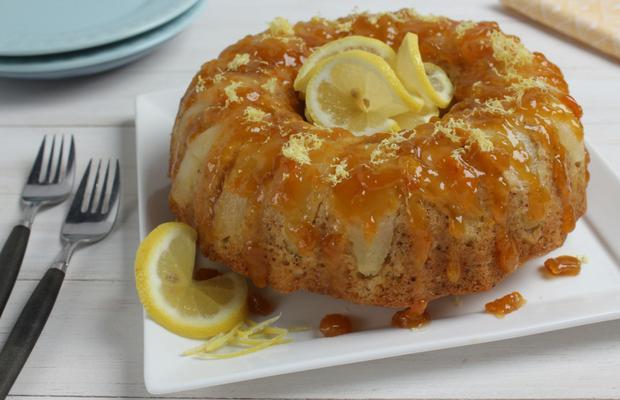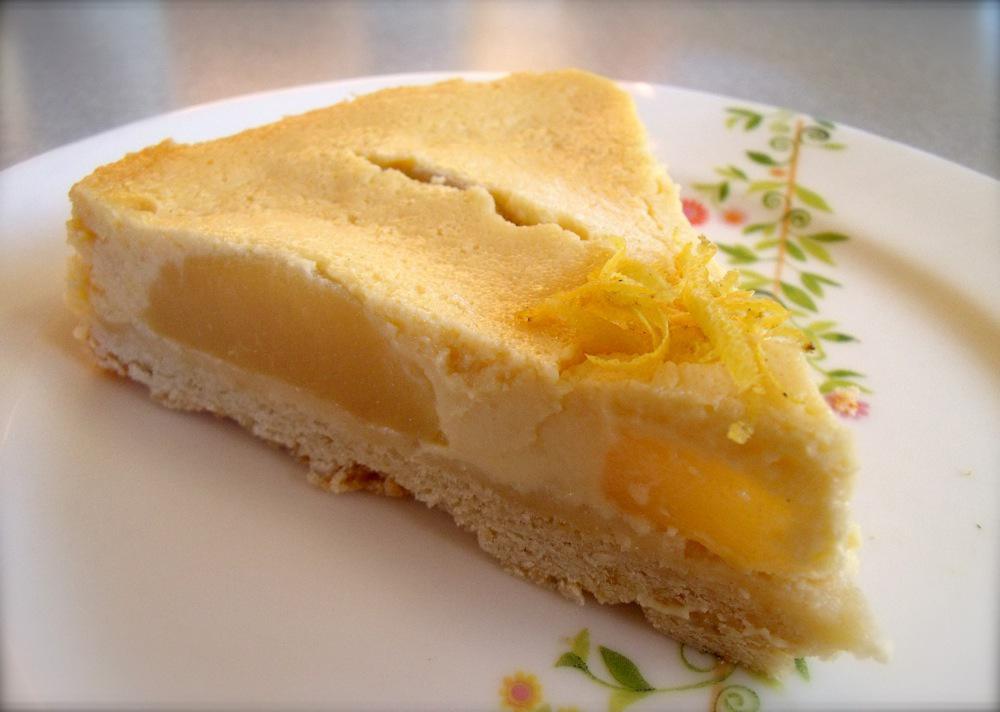The first image is the image on the left, the second image is the image on the right. Analyze the images presented: Is the assertion "there is cake with lemons being used as decorations and a metal utencil is near the cake" valid? Answer yes or no. Yes. The first image is the image on the left, the second image is the image on the right. Assess this claim about the two images: "In one of the images, there is a piece of fresh lemon sitting beside the dough.". Correct or not? Answer yes or no. Yes. 